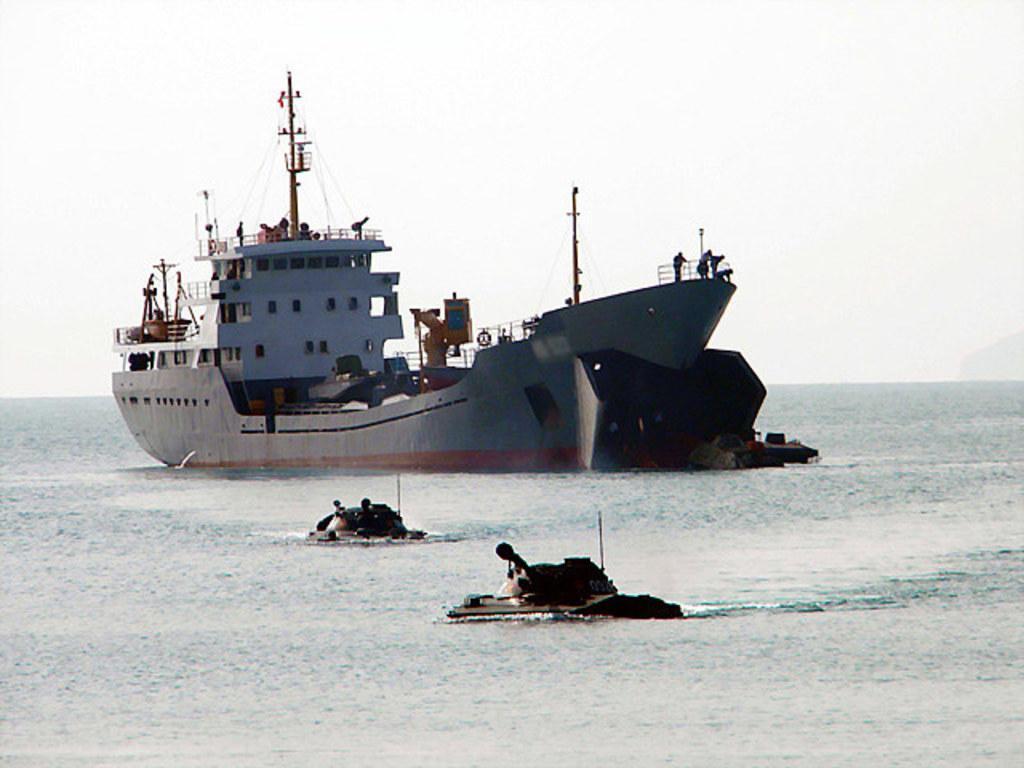Describe this image in one or two sentences. In this image there is a big ship in the water. In the ship there is a building and some poles. At the top there is the sky and there are two small boats in the water. 